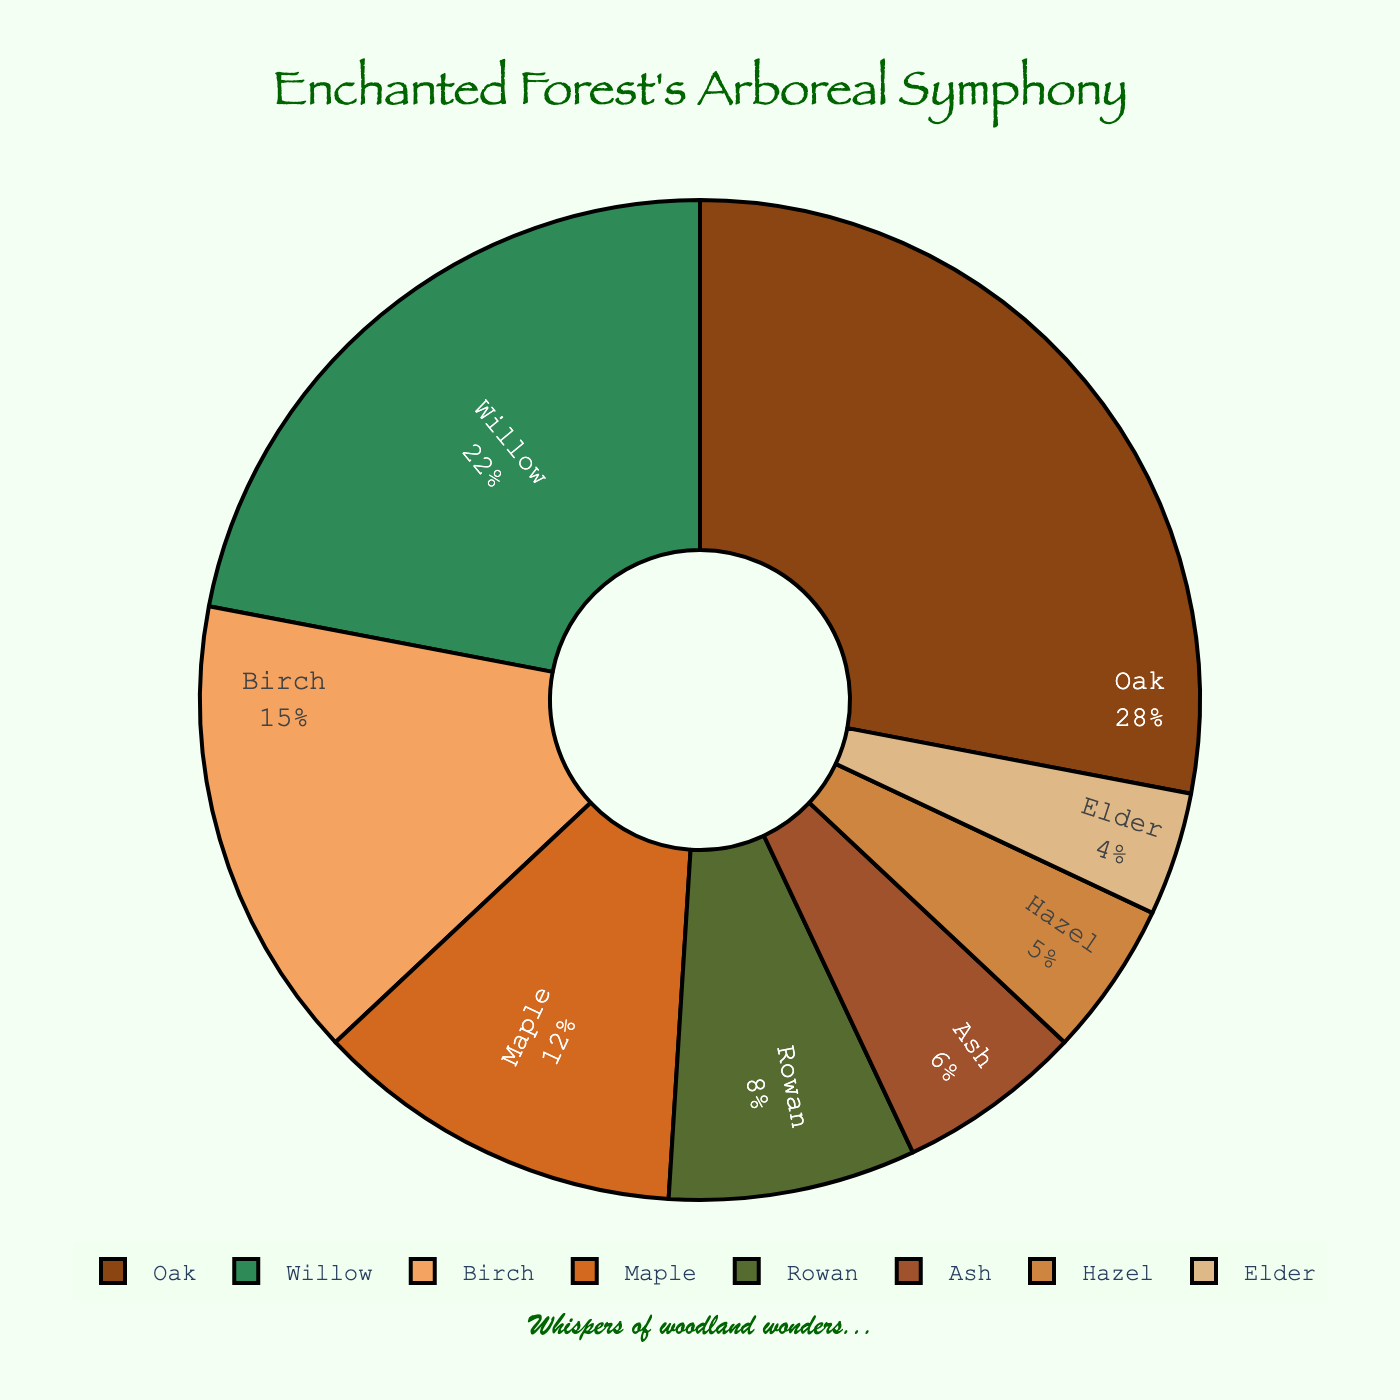What's the proportion of Willow trees in this enchanted forest? From the pie chart, we can see that the Willow trees occupy a specific segment of the chart. The label on the Willow segment indicates it represents 22% of the forest.
Answer: 22% Which type of tree is the least common in the forest? Observing the pie chart, the Elder tree segment is the smallest in size and percentage. The label on this segment notes that it accounts for only 4% of the forest.
Answer: Elder How much greater is the proportion of Oak trees compared to Hazel trees? The Oak trees cover 28% of the forest while Hazel covers 5%. The difference can be calculated as 28% - 5% = 23%.
Answer: 23% What is the combined percentage of Birch, Rowan, and Ash trees? According to the chart, Birch is 15%, Rowan is 8%, and Ash is 6%. Summing these values, we get 15% + 8% + 6% = 29%.
Answer: 29% Which tree type accounts for a larger portion of the forest, Maple or Hazel? From the chart, the Maple tree segment shows 12%, and the Hazel tree segment shows 5%. Therefore, Maple has a larger proportion than Hazel.
Answer: Maple Is the proportion of Willow trees more than double that of Ash trees? The Willow trees represent 22% of the forest, while Ash trees represent 6%. Doubling the Ash tree percentage gives 6% * 2 = 12%. Since 22% is greater than 12%, the proportion of Willow trees is more than double that of Ash trees.
Answer: Yes What is the total percentage represented by Maple, Rowan, and Elder trees combined? The chart shows Maple at 12%, Rowan at 8%, and Elder at 4%. Adding these together gives 12% + 8% + 4% = 24%.
Answer: 24% Which two types of trees together make up just over a third of the forest? One third of the forest is approximately 33.33%. The Oak (28%) and Elder (4%) together equal 28% + 4% = 32%, which is close but not over. The Oak (28%) and Birch (15%) add up to 43%, which is over. The Willow (22%) and Birch (15%) add up to 37%, which is just over a third.
Answer: Willow and Birch Do Oak and Maple trees together represent more than half of the forest? Oak trees represent 28% and Maple trees represent 12%, together they make up 28% + 12% = 40%. Since 40% is less than half, they don't represent more than half of the forest.
Answer: No 